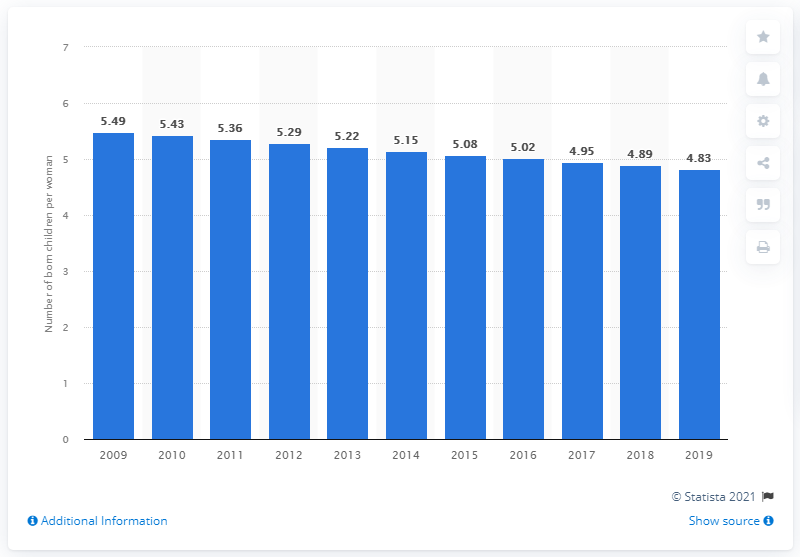List a handful of essential elements in this visual. According to data from 2019, the fertility rate in Tanzania was 4.83. 